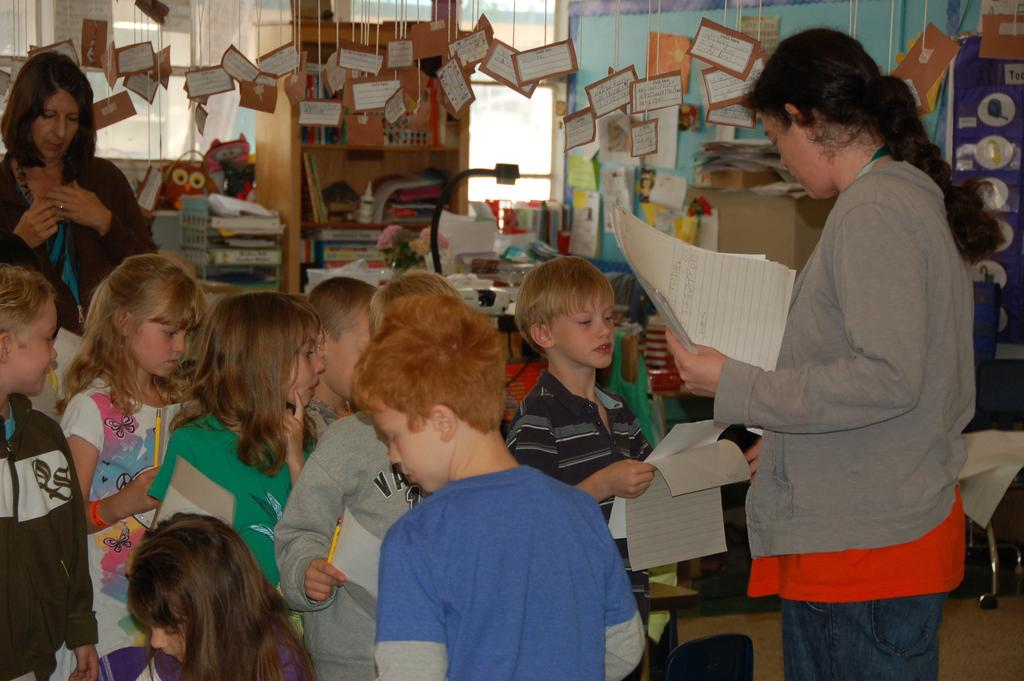How many people are in the image? There are people in the image, but the exact number is not specified. What are some people holding in the image? Some people are holding papers and pencils in the image. What can be seen on the walls in the image? There are posters in the image. What type of furniture is present in the image? There is a cupboard with objects in the image. What other objects can be seen in the image? There are other objects in the image, but their specific nature is not mentioned. How many times does the person sneeze in the image? There is no person sneezing in the image, and therefore no such activity can be observed. What type of bike is visible in the image? There is no bike present in the image. 